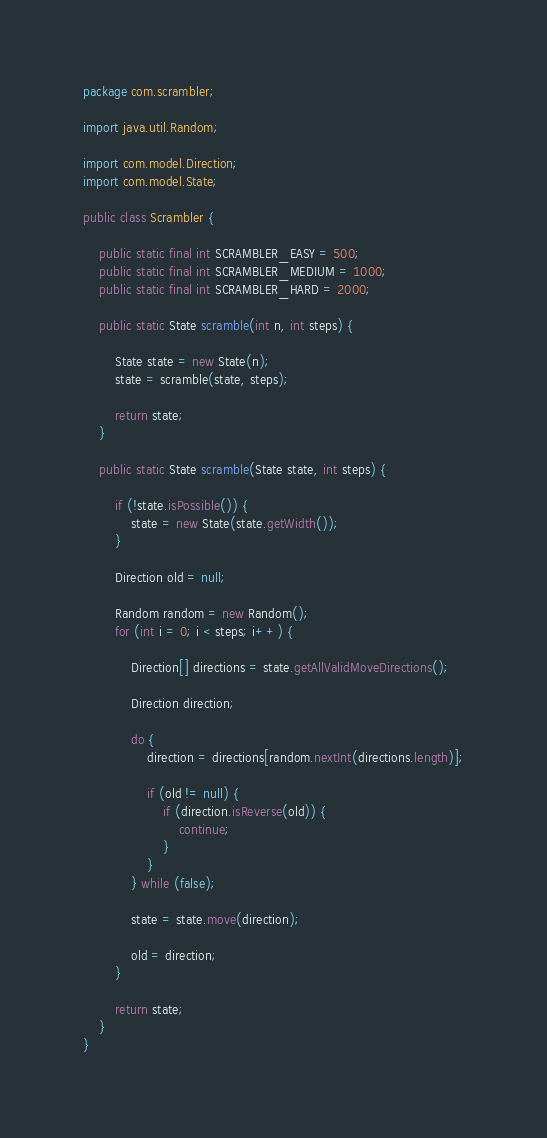<code> <loc_0><loc_0><loc_500><loc_500><_Java_>package com.scrambler;

import java.util.Random;

import com.model.Direction;
import com.model.State;

public class Scrambler {

	public static final int SCRAMBLER_EASY = 500;
	public static final int SCRAMBLER_MEDIUM = 1000;
	public static final int SCRAMBLER_HARD = 2000;

	public static State scramble(int n, int steps) {

		State state = new State(n);
		state = scramble(state, steps);

		return state;
	}

	public static State scramble(State state, int steps) {

		if (!state.isPossible()) {
			state = new State(state.getWidth());
		}

		Direction old = null;

		Random random = new Random();
		for (int i = 0; i < steps; i++) {

			Direction[] directions = state.getAllValidMoveDirections();

			Direction direction;

			do {
				direction = directions[random.nextInt(directions.length)];

				if (old != null) {
					if (direction.isReverse(old)) {
						continue;
					}
				}
			} while (false);

			state = state.move(direction);

			old = direction;
		}

		return state;
	}
}</code> 